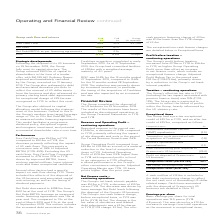According to Greencore Group Plc's financial document, What was the free cash flow in FY19? According to the financial document, £54.9m. The relevant text states: "Performance Free Cash Flow was £54.9m in FY19 compared to £92.4m in FY18, the decrease primarily reflecting the impact of US cash flows. T..." Also, What factors had a specific impact on cash flow during FY19? the effects of the disposal of the US business and associated capital restructuring, as well as the timing of dividend payments.. The document states: "ic impact on cash flow during FY19. These included the effects of the disposal of the US business and associated capital restructuring, as well as the..." Also, What was the Net Debt in FY18?  According to the financial document, £288.5m. The relevant text states: "Net Debt decreased to £288.5m from £501.1m at the end of FY18. The Group’s Net Debt:EBITDA leverage as measured under financing ag..." Also, can you calculate: What was the percentage change in the free cash flow from FY18 to FY19? To answer this question, I need to perform calculations using the financial data. The calculation is: (54.9-92.4)/92.4, which equals -40.58 (percentage). This is based on the information: "Free Cash Flow 54.9 92.4 -£37.5m Free Cash Flow 54.9 92.4 -£37.5m..." The key data points involved are: 54.9, 92.4. Also, can you calculate: What is the average net debt for FY18 and FY19? To answer this question, I need to perform calculations using the financial data. The calculation is: (288.5 + 501.1) / 2, which equals 394.8 (in millions). This is based on the information: "Net Debt 288.5 501.1 Net Debt 288.5 501.1..." The key data points involved are: 288.5, 501.1. Also, can you calculate: What is the change in the net debt:EBITDA as per financing agreements from FY18 to FY19? Based on the calculation: 1.8 - 2.3, the result is -0.5. This is based on the information: "Net Debt:EBITDA as per financing agreements 1.8x 2.3x Net Debt:EBITDA as per financing agreements 1.8x 2.3x..." The key data points involved are: 1.8, 2.3. 